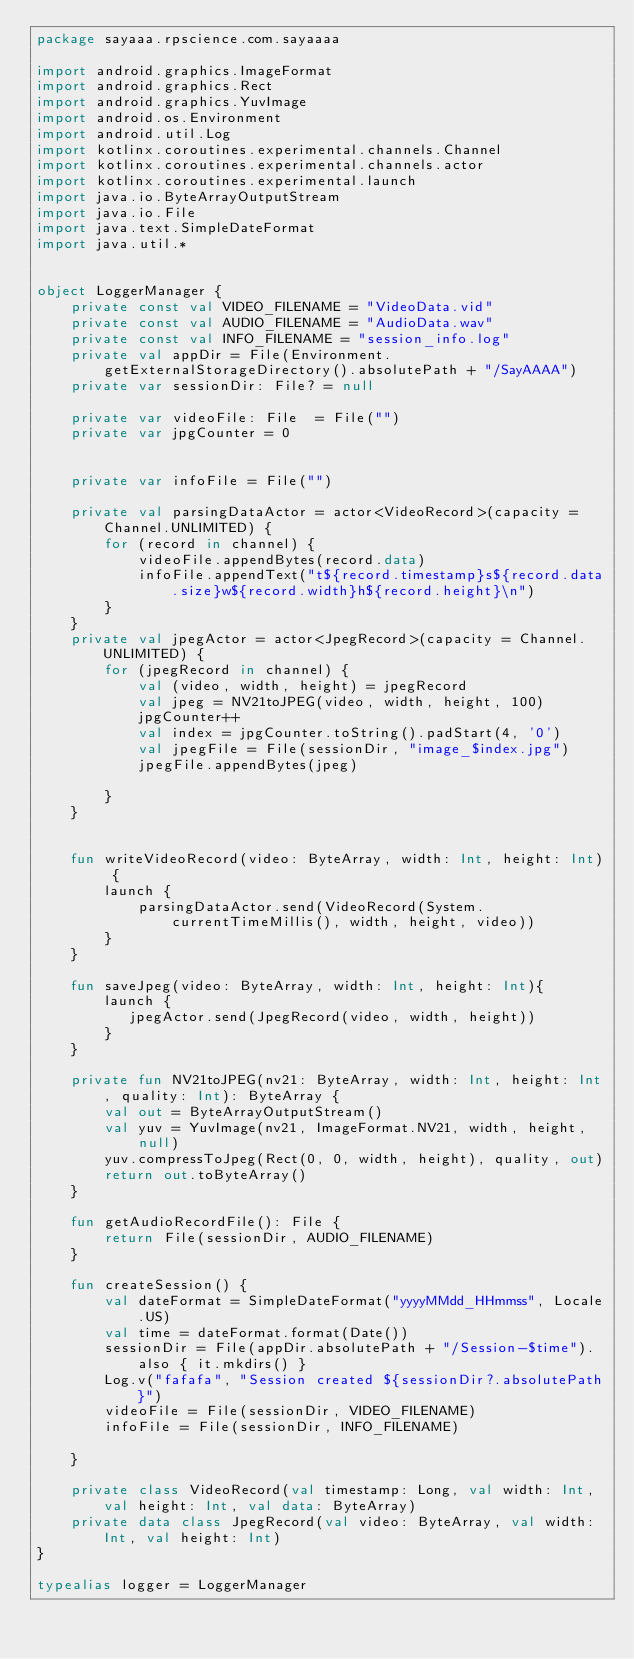<code> <loc_0><loc_0><loc_500><loc_500><_Kotlin_>package sayaaa.rpscience.com.sayaaaa

import android.graphics.ImageFormat
import android.graphics.Rect
import android.graphics.YuvImage
import android.os.Environment
import android.util.Log
import kotlinx.coroutines.experimental.channels.Channel
import kotlinx.coroutines.experimental.channels.actor
import kotlinx.coroutines.experimental.launch
import java.io.ByteArrayOutputStream
import java.io.File
import java.text.SimpleDateFormat
import java.util.*


object LoggerManager {
    private const val VIDEO_FILENAME = "VideoData.vid"
    private const val AUDIO_FILENAME = "AudioData.wav"
    private const val INFO_FILENAME = "session_info.log"
    private val appDir = File(Environment.getExternalStorageDirectory().absolutePath + "/SayAAAA")
    private var sessionDir: File? = null

    private var videoFile: File  = File("")
    private var jpgCounter = 0


    private var infoFile = File("")

    private val parsingDataActor = actor<VideoRecord>(capacity = Channel.UNLIMITED) {
        for (record in channel) {
            videoFile.appendBytes(record.data)
            infoFile.appendText("t${record.timestamp}s${record.data.size}w${record.width}h${record.height}\n")
        }
    }
    private val jpegActor = actor<JpegRecord>(capacity = Channel.UNLIMITED) {
        for (jpegRecord in channel) {
            val (video, width, height) = jpegRecord
            val jpeg = NV21toJPEG(video, width, height, 100)
            jpgCounter++
            val index = jpgCounter.toString().padStart(4, '0')
            val jpegFile = File(sessionDir, "image_$index.jpg")
            jpegFile.appendBytes(jpeg)

        }
    }


    fun writeVideoRecord(video: ByteArray, width: Int, height: Int) {
        launch {
            parsingDataActor.send(VideoRecord(System.currentTimeMillis(), width, height, video))
        }
    }

    fun saveJpeg(video: ByteArray, width: Int, height: Int){
        launch {
           jpegActor.send(JpegRecord(video, width, height))
        }
    }

    private fun NV21toJPEG(nv21: ByteArray, width: Int, height: Int, quality: Int): ByteArray {
        val out = ByteArrayOutputStream()
        val yuv = YuvImage(nv21, ImageFormat.NV21, width, height, null)
        yuv.compressToJpeg(Rect(0, 0, width, height), quality, out)
        return out.toByteArray()
    }

    fun getAudioRecordFile(): File {
        return File(sessionDir, AUDIO_FILENAME)
    }

    fun createSession() {
        val dateFormat = SimpleDateFormat("yyyyMMdd_HHmmss", Locale.US)
        val time = dateFormat.format(Date())
        sessionDir = File(appDir.absolutePath + "/Session-$time").also { it.mkdirs() }
        Log.v("fafafa", "Session created ${sessionDir?.absolutePath}")
        videoFile = File(sessionDir, VIDEO_FILENAME)
        infoFile = File(sessionDir, INFO_FILENAME)

    }

    private class VideoRecord(val timestamp: Long, val width: Int, val height: Int, val data: ByteArray)
    private data class JpegRecord(val video: ByteArray, val width: Int, val height: Int)
}

typealias logger = LoggerManager</code> 